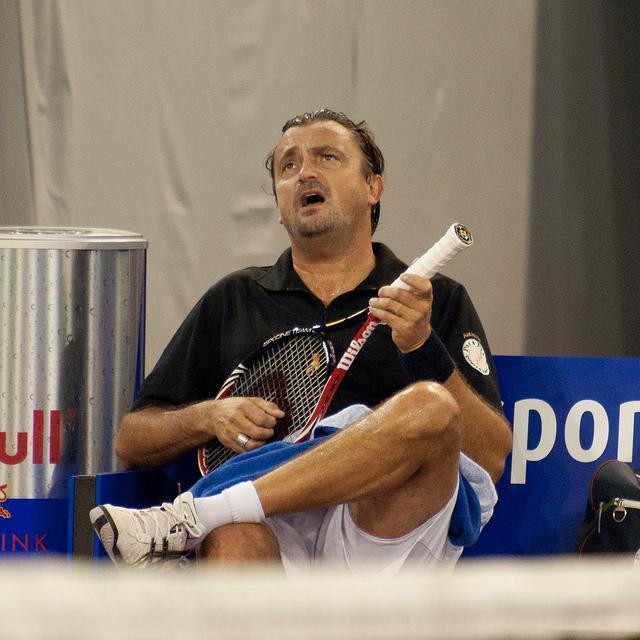How many giraffes are in this scene?
Give a very brief answer. 0. 